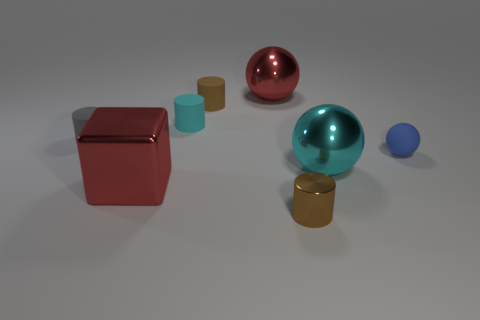Are there any rubber things of the same size as the brown metallic thing?
Offer a terse response. Yes. What material is the large sphere that is behind the blue object?
Ensure brevity in your answer.  Metal. Do the small cylinder that is in front of the small blue sphere and the red block have the same material?
Provide a short and direct response. Yes. What shape is the cyan thing that is the same size as the brown metal cylinder?
Make the answer very short. Cylinder. What number of other spheres have the same color as the rubber sphere?
Give a very brief answer. 0. Are there fewer blocks that are behind the large red metal cube than red things that are in front of the gray matte cylinder?
Ensure brevity in your answer.  Yes. Are there any big spheres right of the matte sphere?
Your answer should be very brief. No. Is there a small brown cylinder that is behind the big red metal object on the left side of the metal ball that is behind the small gray rubber cylinder?
Provide a succinct answer. Yes. There is a red shiny thing in front of the large red metal ball; is its shape the same as the small brown shiny thing?
Provide a short and direct response. No. The cylinder that is made of the same material as the red cube is what color?
Offer a very short reply. Brown. 